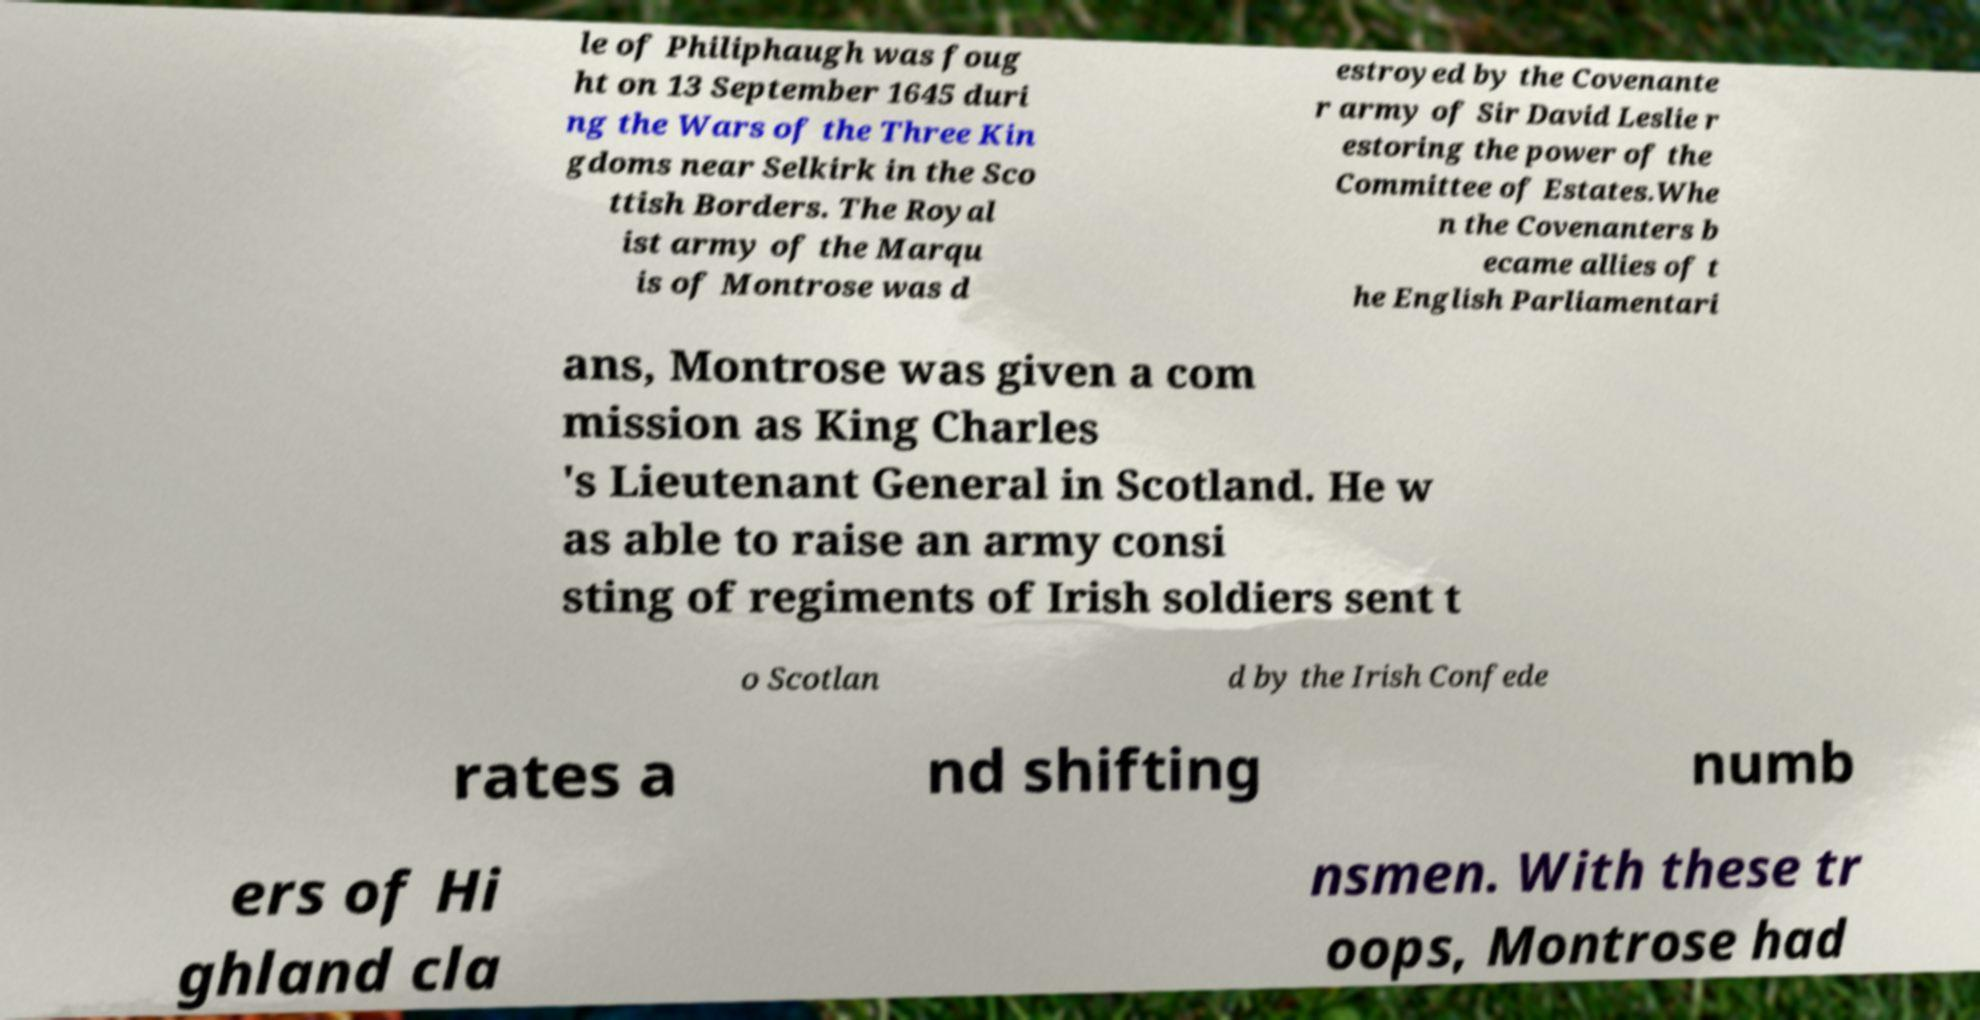Please identify and transcribe the text found in this image. le of Philiphaugh was foug ht on 13 September 1645 duri ng the Wars of the Three Kin gdoms near Selkirk in the Sco ttish Borders. The Royal ist army of the Marqu is of Montrose was d estroyed by the Covenante r army of Sir David Leslie r estoring the power of the Committee of Estates.Whe n the Covenanters b ecame allies of t he English Parliamentari ans, Montrose was given a com mission as King Charles 's Lieutenant General in Scotland. He w as able to raise an army consi sting of regiments of Irish soldiers sent t o Scotlan d by the Irish Confede rates a nd shifting numb ers of Hi ghland cla nsmen. With these tr oops, Montrose had 